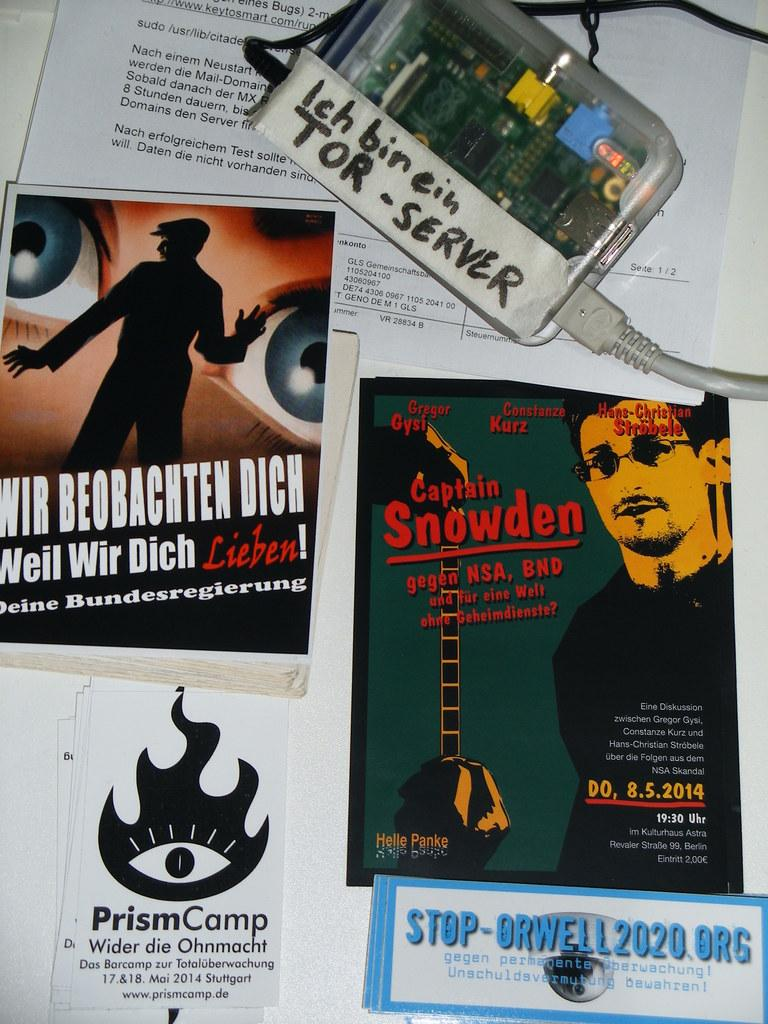What is the main piece of furniture in the image? There is a table in the image. What items can be seen on the table? There are books, papers, a chip, and wires on the table. What might be used for reading or writing in the image? The books and papers on the table might be used for reading or writing. Is there any quicksand visible in the image? No, there is no quicksand present in the image. What type of holiday is being celebrated in the image? There is no indication of a holiday being celebrated in the image. 